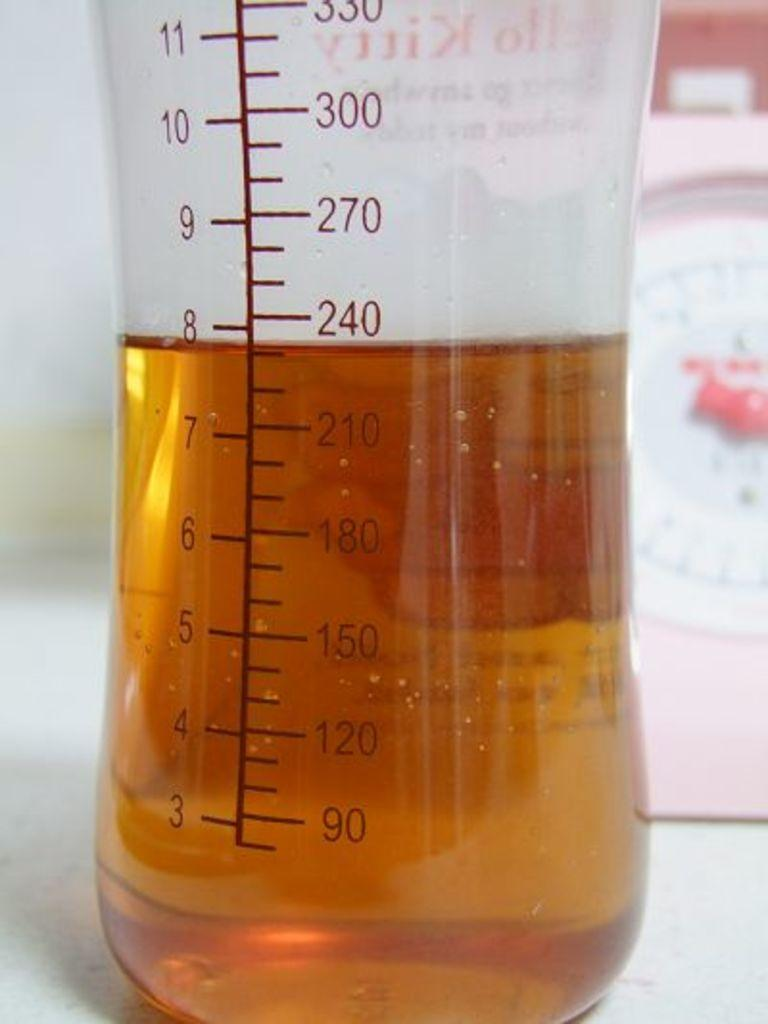What is in the bottle that is visible in the image? There is a drink in the bottle that is visible in the image. Where is the bottle located in the image? The bottle is in the middle of the image. What can be seen on the right side of the image? There is a clock on the right side of the image. What type of jam is being spread on the wren in the image? There is no jam or wren present in the image; it only features a bottle with a drink and a clock. 